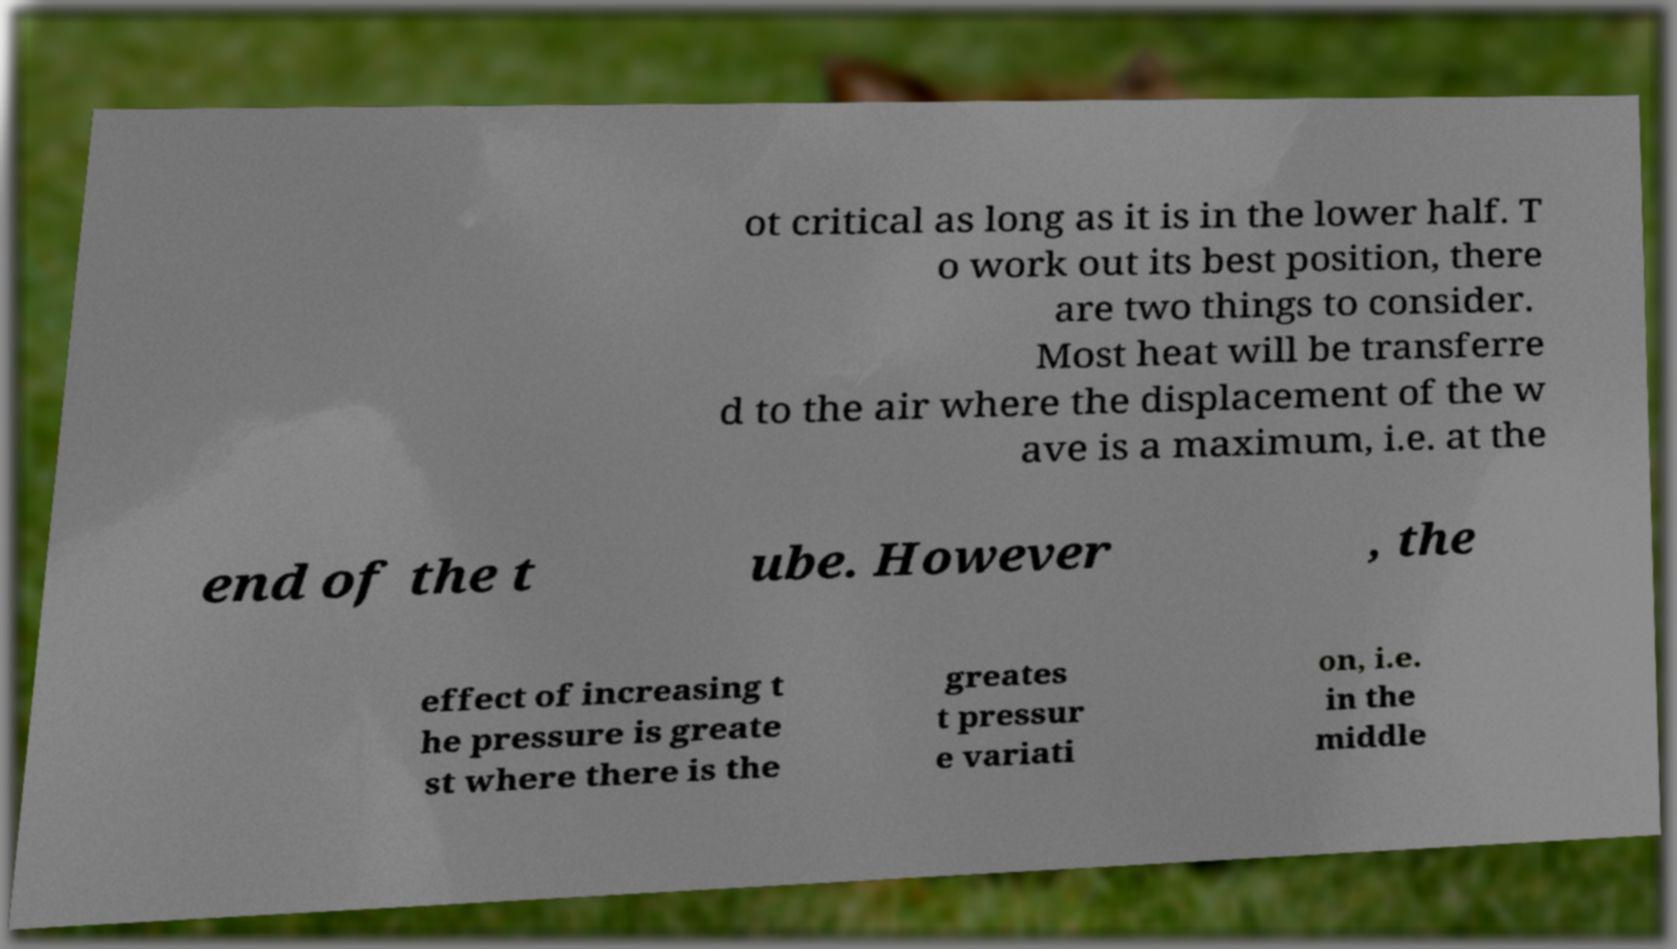I need the written content from this picture converted into text. Can you do that? ot critical as long as it is in the lower half. T o work out its best position, there are two things to consider. Most heat will be transferre d to the air where the displacement of the w ave is a maximum, i.e. at the end of the t ube. However , the effect of increasing t he pressure is greate st where there is the greates t pressur e variati on, i.e. in the middle 